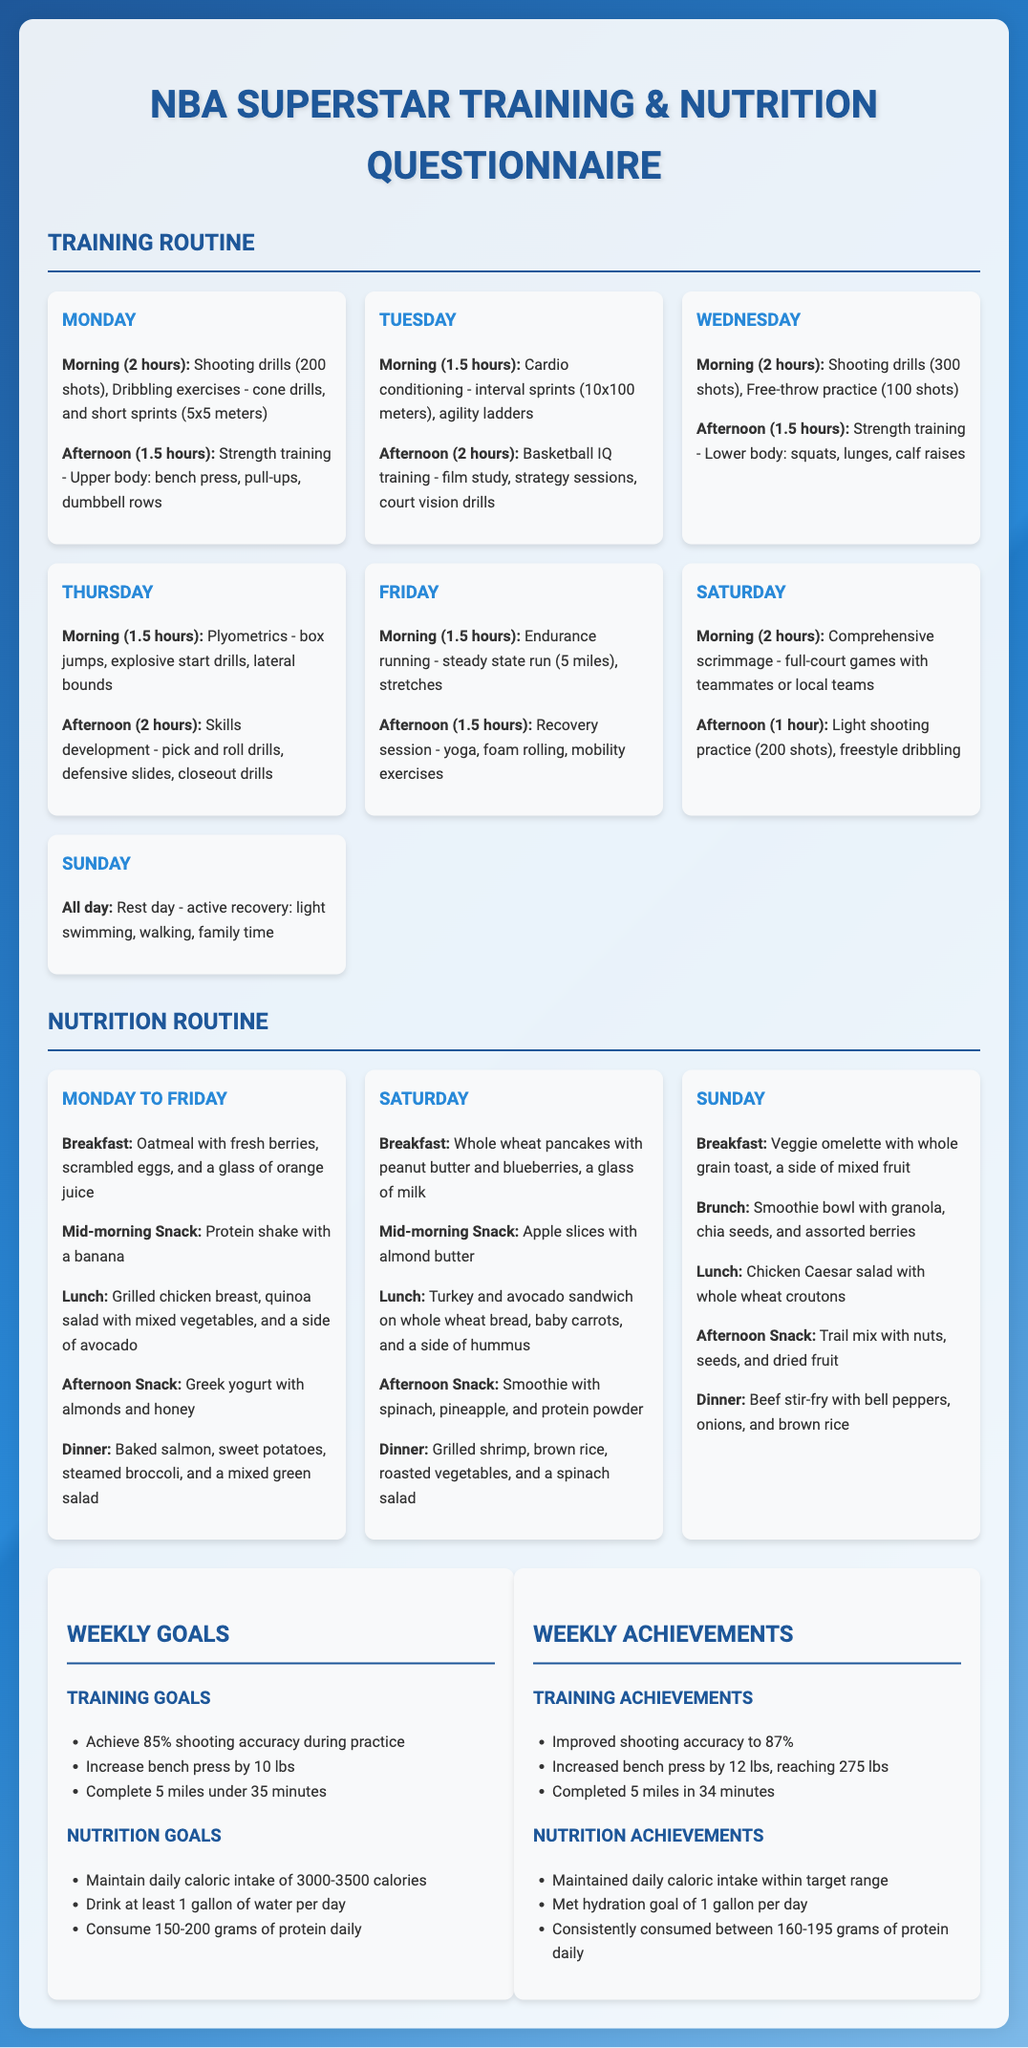What is the total number of shooting drills performed on Wednesday? The document states that 300 shots were performed in shooting drills on Wednesday.
Answer: 300 shots How many days include morning training sessions? The document lists training sessions for each day of the week, indicating that there are morning sessions every day except Sunday.
Answer: 6 days What is the weekly goal for water intake? The weekly goal for hydration is to drink at least 1 gallon of water per day.
Answer: 1 gallon What type of training is focused on Thursday afternoon? The document specifies that skills development is the focus of Thursday afternoon training.
Answer: Skills development What is the difference in shooting accuracy achieved compared to the goal? The document states that the training goal was to achieve 85% shooting accuracy, and the achievement reached 87%. The difference is 2%.
Answer: 2% Which day features comprehensive scrimmage? According to the document, comprehensive scrimmage occurs on Saturday morning.
Answer: Saturday How many grams of protein are aimed for daily intake? The nutrition goals specify that the daily protein intake target is 150-200 grams.
Answer: 150-200 grams What exercise is included in strength training on Monday? The document lists bench press as one of the exercises in strength training on Monday.
Answer: Bench press 